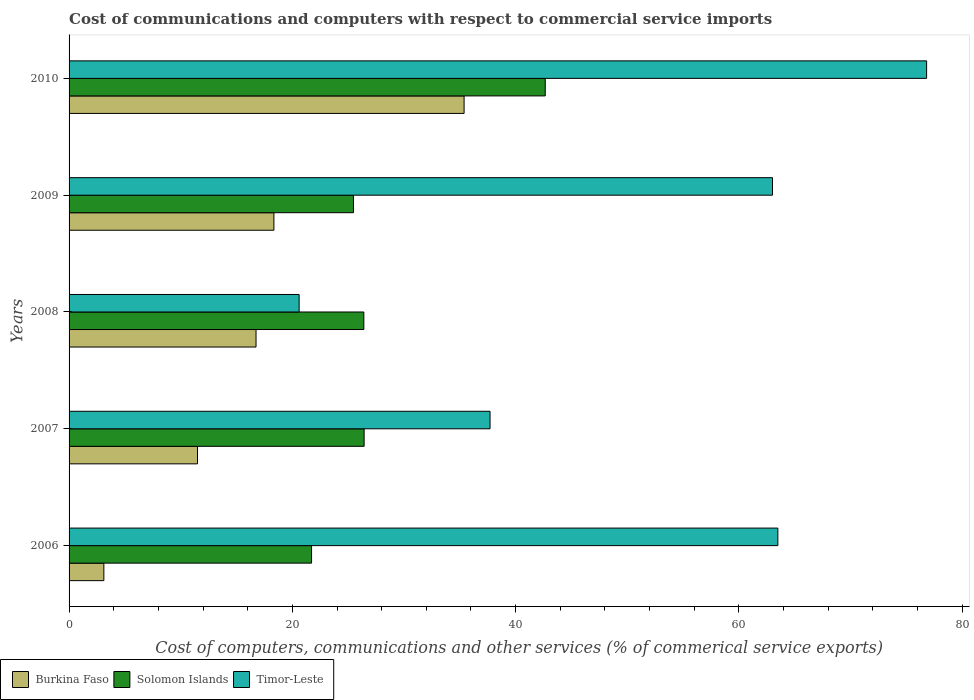How many groups of bars are there?
Your response must be concise. 5. Are the number of bars per tick equal to the number of legend labels?
Your answer should be very brief. Yes. Are the number of bars on each tick of the Y-axis equal?
Ensure brevity in your answer.  Yes. In how many cases, is the number of bars for a given year not equal to the number of legend labels?
Keep it short and to the point. 0. What is the cost of communications and computers in Burkina Faso in 2006?
Offer a very short reply. 3.12. Across all years, what is the maximum cost of communications and computers in Burkina Faso?
Offer a very short reply. 35.38. Across all years, what is the minimum cost of communications and computers in Solomon Islands?
Give a very brief answer. 21.72. In which year was the cost of communications and computers in Timor-Leste maximum?
Offer a very short reply. 2010. What is the total cost of communications and computers in Timor-Leste in the graph?
Keep it short and to the point. 261.62. What is the difference between the cost of communications and computers in Solomon Islands in 2006 and that in 2010?
Offer a terse response. -20.93. What is the difference between the cost of communications and computers in Timor-Leste in 2010 and the cost of communications and computers in Burkina Faso in 2009?
Make the answer very short. 58.46. What is the average cost of communications and computers in Burkina Faso per year?
Your answer should be very brief. 17.02. In the year 2006, what is the difference between the cost of communications and computers in Timor-Leste and cost of communications and computers in Burkina Faso?
Offer a terse response. 60.37. In how many years, is the cost of communications and computers in Timor-Leste greater than 56 %?
Make the answer very short. 3. What is the ratio of the cost of communications and computers in Burkina Faso in 2008 to that in 2010?
Ensure brevity in your answer.  0.47. Is the difference between the cost of communications and computers in Timor-Leste in 2007 and 2008 greater than the difference between the cost of communications and computers in Burkina Faso in 2007 and 2008?
Your response must be concise. Yes. What is the difference between the highest and the second highest cost of communications and computers in Solomon Islands?
Offer a very short reply. 16.22. What is the difference between the highest and the lowest cost of communications and computers in Burkina Faso?
Your response must be concise. 32.27. In how many years, is the cost of communications and computers in Solomon Islands greater than the average cost of communications and computers in Solomon Islands taken over all years?
Keep it short and to the point. 1. Is the sum of the cost of communications and computers in Timor-Leste in 2007 and 2008 greater than the maximum cost of communications and computers in Solomon Islands across all years?
Offer a terse response. Yes. What does the 1st bar from the top in 2006 represents?
Provide a succinct answer. Timor-Leste. What does the 2nd bar from the bottom in 2009 represents?
Your answer should be very brief. Solomon Islands. Is it the case that in every year, the sum of the cost of communications and computers in Burkina Faso and cost of communications and computers in Solomon Islands is greater than the cost of communications and computers in Timor-Leste?
Your response must be concise. No. Are all the bars in the graph horizontal?
Provide a succinct answer. Yes. How many years are there in the graph?
Provide a short and direct response. 5. What is the difference between two consecutive major ticks on the X-axis?
Make the answer very short. 20. Are the values on the major ticks of X-axis written in scientific E-notation?
Ensure brevity in your answer.  No. Does the graph contain grids?
Your answer should be very brief. No. How many legend labels are there?
Offer a very short reply. 3. What is the title of the graph?
Ensure brevity in your answer.  Cost of communications and computers with respect to commercial service imports. What is the label or title of the X-axis?
Provide a short and direct response. Cost of computers, communications and other services (% of commerical service exports). What is the label or title of the Y-axis?
Offer a terse response. Years. What is the Cost of computers, communications and other services (% of commerical service exports) of Burkina Faso in 2006?
Provide a succinct answer. 3.12. What is the Cost of computers, communications and other services (% of commerical service exports) of Solomon Islands in 2006?
Ensure brevity in your answer.  21.72. What is the Cost of computers, communications and other services (% of commerical service exports) in Timor-Leste in 2006?
Keep it short and to the point. 63.49. What is the Cost of computers, communications and other services (% of commerical service exports) in Burkina Faso in 2007?
Your response must be concise. 11.51. What is the Cost of computers, communications and other services (% of commerical service exports) in Solomon Islands in 2007?
Offer a terse response. 26.43. What is the Cost of computers, communications and other services (% of commerical service exports) in Timor-Leste in 2007?
Offer a terse response. 37.71. What is the Cost of computers, communications and other services (% of commerical service exports) of Burkina Faso in 2008?
Your answer should be very brief. 16.75. What is the Cost of computers, communications and other services (% of commerical service exports) of Solomon Islands in 2008?
Keep it short and to the point. 26.4. What is the Cost of computers, communications and other services (% of commerical service exports) of Timor-Leste in 2008?
Your answer should be very brief. 20.61. What is the Cost of computers, communications and other services (% of commerical service exports) in Burkina Faso in 2009?
Your answer should be compact. 18.35. What is the Cost of computers, communications and other services (% of commerical service exports) in Solomon Islands in 2009?
Your answer should be very brief. 25.47. What is the Cost of computers, communications and other services (% of commerical service exports) of Timor-Leste in 2009?
Ensure brevity in your answer.  63.01. What is the Cost of computers, communications and other services (% of commerical service exports) of Burkina Faso in 2010?
Provide a succinct answer. 35.38. What is the Cost of computers, communications and other services (% of commerical service exports) of Solomon Islands in 2010?
Ensure brevity in your answer.  42.65. What is the Cost of computers, communications and other services (% of commerical service exports) of Timor-Leste in 2010?
Ensure brevity in your answer.  76.81. Across all years, what is the maximum Cost of computers, communications and other services (% of commerical service exports) in Burkina Faso?
Make the answer very short. 35.38. Across all years, what is the maximum Cost of computers, communications and other services (% of commerical service exports) in Solomon Islands?
Make the answer very short. 42.65. Across all years, what is the maximum Cost of computers, communications and other services (% of commerical service exports) of Timor-Leste?
Make the answer very short. 76.81. Across all years, what is the minimum Cost of computers, communications and other services (% of commerical service exports) in Burkina Faso?
Offer a very short reply. 3.12. Across all years, what is the minimum Cost of computers, communications and other services (% of commerical service exports) of Solomon Islands?
Your response must be concise. 21.72. Across all years, what is the minimum Cost of computers, communications and other services (% of commerical service exports) of Timor-Leste?
Make the answer very short. 20.61. What is the total Cost of computers, communications and other services (% of commerical service exports) in Burkina Faso in the graph?
Offer a terse response. 85.1. What is the total Cost of computers, communications and other services (% of commerical service exports) of Solomon Islands in the graph?
Ensure brevity in your answer.  142.68. What is the total Cost of computers, communications and other services (% of commerical service exports) of Timor-Leste in the graph?
Your answer should be compact. 261.62. What is the difference between the Cost of computers, communications and other services (% of commerical service exports) in Burkina Faso in 2006 and that in 2007?
Make the answer very short. -8.39. What is the difference between the Cost of computers, communications and other services (% of commerical service exports) in Solomon Islands in 2006 and that in 2007?
Keep it short and to the point. -4.71. What is the difference between the Cost of computers, communications and other services (% of commerical service exports) of Timor-Leste in 2006 and that in 2007?
Give a very brief answer. 25.78. What is the difference between the Cost of computers, communications and other services (% of commerical service exports) in Burkina Faso in 2006 and that in 2008?
Keep it short and to the point. -13.63. What is the difference between the Cost of computers, communications and other services (% of commerical service exports) of Solomon Islands in 2006 and that in 2008?
Make the answer very short. -4.68. What is the difference between the Cost of computers, communications and other services (% of commerical service exports) in Timor-Leste in 2006 and that in 2008?
Provide a succinct answer. 42.88. What is the difference between the Cost of computers, communications and other services (% of commerical service exports) of Burkina Faso in 2006 and that in 2009?
Provide a short and direct response. -15.23. What is the difference between the Cost of computers, communications and other services (% of commerical service exports) in Solomon Islands in 2006 and that in 2009?
Ensure brevity in your answer.  -3.75. What is the difference between the Cost of computers, communications and other services (% of commerical service exports) in Timor-Leste in 2006 and that in 2009?
Your response must be concise. 0.48. What is the difference between the Cost of computers, communications and other services (% of commerical service exports) of Burkina Faso in 2006 and that in 2010?
Provide a short and direct response. -32.27. What is the difference between the Cost of computers, communications and other services (% of commerical service exports) of Solomon Islands in 2006 and that in 2010?
Offer a very short reply. -20.93. What is the difference between the Cost of computers, communications and other services (% of commerical service exports) of Timor-Leste in 2006 and that in 2010?
Provide a short and direct response. -13.32. What is the difference between the Cost of computers, communications and other services (% of commerical service exports) of Burkina Faso in 2007 and that in 2008?
Give a very brief answer. -5.24. What is the difference between the Cost of computers, communications and other services (% of commerical service exports) in Solomon Islands in 2007 and that in 2008?
Your response must be concise. 0.03. What is the difference between the Cost of computers, communications and other services (% of commerical service exports) in Timor-Leste in 2007 and that in 2008?
Provide a succinct answer. 17.1. What is the difference between the Cost of computers, communications and other services (% of commerical service exports) in Burkina Faso in 2007 and that in 2009?
Offer a very short reply. -6.84. What is the difference between the Cost of computers, communications and other services (% of commerical service exports) in Solomon Islands in 2007 and that in 2009?
Keep it short and to the point. 0.95. What is the difference between the Cost of computers, communications and other services (% of commerical service exports) in Timor-Leste in 2007 and that in 2009?
Your answer should be compact. -25.3. What is the difference between the Cost of computers, communications and other services (% of commerical service exports) in Burkina Faso in 2007 and that in 2010?
Your answer should be very brief. -23.88. What is the difference between the Cost of computers, communications and other services (% of commerical service exports) of Solomon Islands in 2007 and that in 2010?
Your answer should be very brief. -16.22. What is the difference between the Cost of computers, communications and other services (% of commerical service exports) in Timor-Leste in 2007 and that in 2010?
Keep it short and to the point. -39.1. What is the difference between the Cost of computers, communications and other services (% of commerical service exports) in Burkina Faso in 2008 and that in 2009?
Ensure brevity in your answer.  -1.6. What is the difference between the Cost of computers, communications and other services (% of commerical service exports) in Solomon Islands in 2008 and that in 2009?
Offer a very short reply. 0.93. What is the difference between the Cost of computers, communications and other services (% of commerical service exports) in Timor-Leste in 2008 and that in 2009?
Your answer should be very brief. -42.4. What is the difference between the Cost of computers, communications and other services (% of commerical service exports) in Burkina Faso in 2008 and that in 2010?
Offer a very short reply. -18.64. What is the difference between the Cost of computers, communications and other services (% of commerical service exports) of Solomon Islands in 2008 and that in 2010?
Your answer should be very brief. -16.25. What is the difference between the Cost of computers, communications and other services (% of commerical service exports) of Timor-Leste in 2008 and that in 2010?
Ensure brevity in your answer.  -56.21. What is the difference between the Cost of computers, communications and other services (% of commerical service exports) in Burkina Faso in 2009 and that in 2010?
Provide a succinct answer. -17.04. What is the difference between the Cost of computers, communications and other services (% of commerical service exports) in Solomon Islands in 2009 and that in 2010?
Keep it short and to the point. -17.18. What is the difference between the Cost of computers, communications and other services (% of commerical service exports) of Timor-Leste in 2009 and that in 2010?
Provide a short and direct response. -13.8. What is the difference between the Cost of computers, communications and other services (% of commerical service exports) in Burkina Faso in 2006 and the Cost of computers, communications and other services (% of commerical service exports) in Solomon Islands in 2007?
Provide a succinct answer. -23.31. What is the difference between the Cost of computers, communications and other services (% of commerical service exports) in Burkina Faso in 2006 and the Cost of computers, communications and other services (% of commerical service exports) in Timor-Leste in 2007?
Ensure brevity in your answer.  -34.59. What is the difference between the Cost of computers, communications and other services (% of commerical service exports) of Solomon Islands in 2006 and the Cost of computers, communications and other services (% of commerical service exports) of Timor-Leste in 2007?
Offer a very short reply. -15.99. What is the difference between the Cost of computers, communications and other services (% of commerical service exports) of Burkina Faso in 2006 and the Cost of computers, communications and other services (% of commerical service exports) of Solomon Islands in 2008?
Provide a short and direct response. -23.29. What is the difference between the Cost of computers, communications and other services (% of commerical service exports) in Burkina Faso in 2006 and the Cost of computers, communications and other services (% of commerical service exports) in Timor-Leste in 2008?
Give a very brief answer. -17.49. What is the difference between the Cost of computers, communications and other services (% of commerical service exports) in Solomon Islands in 2006 and the Cost of computers, communications and other services (% of commerical service exports) in Timor-Leste in 2008?
Give a very brief answer. 1.12. What is the difference between the Cost of computers, communications and other services (% of commerical service exports) in Burkina Faso in 2006 and the Cost of computers, communications and other services (% of commerical service exports) in Solomon Islands in 2009?
Ensure brevity in your answer.  -22.36. What is the difference between the Cost of computers, communications and other services (% of commerical service exports) in Burkina Faso in 2006 and the Cost of computers, communications and other services (% of commerical service exports) in Timor-Leste in 2009?
Your answer should be very brief. -59.89. What is the difference between the Cost of computers, communications and other services (% of commerical service exports) of Solomon Islands in 2006 and the Cost of computers, communications and other services (% of commerical service exports) of Timor-Leste in 2009?
Your answer should be very brief. -41.29. What is the difference between the Cost of computers, communications and other services (% of commerical service exports) of Burkina Faso in 2006 and the Cost of computers, communications and other services (% of commerical service exports) of Solomon Islands in 2010?
Your response must be concise. -39.54. What is the difference between the Cost of computers, communications and other services (% of commerical service exports) in Burkina Faso in 2006 and the Cost of computers, communications and other services (% of commerical service exports) in Timor-Leste in 2010?
Ensure brevity in your answer.  -73.7. What is the difference between the Cost of computers, communications and other services (% of commerical service exports) of Solomon Islands in 2006 and the Cost of computers, communications and other services (% of commerical service exports) of Timor-Leste in 2010?
Your response must be concise. -55.09. What is the difference between the Cost of computers, communications and other services (% of commerical service exports) in Burkina Faso in 2007 and the Cost of computers, communications and other services (% of commerical service exports) in Solomon Islands in 2008?
Provide a succinct answer. -14.9. What is the difference between the Cost of computers, communications and other services (% of commerical service exports) of Burkina Faso in 2007 and the Cost of computers, communications and other services (% of commerical service exports) of Timor-Leste in 2008?
Provide a short and direct response. -9.1. What is the difference between the Cost of computers, communications and other services (% of commerical service exports) in Solomon Islands in 2007 and the Cost of computers, communications and other services (% of commerical service exports) in Timor-Leste in 2008?
Your answer should be compact. 5.82. What is the difference between the Cost of computers, communications and other services (% of commerical service exports) in Burkina Faso in 2007 and the Cost of computers, communications and other services (% of commerical service exports) in Solomon Islands in 2009?
Offer a terse response. -13.97. What is the difference between the Cost of computers, communications and other services (% of commerical service exports) in Burkina Faso in 2007 and the Cost of computers, communications and other services (% of commerical service exports) in Timor-Leste in 2009?
Provide a short and direct response. -51.5. What is the difference between the Cost of computers, communications and other services (% of commerical service exports) of Solomon Islands in 2007 and the Cost of computers, communications and other services (% of commerical service exports) of Timor-Leste in 2009?
Offer a very short reply. -36.58. What is the difference between the Cost of computers, communications and other services (% of commerical service exports) in Burkina Faso in 2007 and the Cost of computers, communications and other services (% of commerical service exports) in Solomon Islands in 2010?
Offer a terse response. -31.15. What is the difference between the Cost of computers, communications and other services (% of commerical service exports) of Burkina Faso in 2007 and the Cost of computers, communications and other services (% of commerical service exports) of Timor-Leste in 2010?
Your answer should be very brief. -65.31. What is the difference between the Cost of computers, communications and other services (% of commerical service exports) of Solomon Islands in 2007 and the Cost of computers, communications and other services (% of commerical service exports) of Timor-Leste in 2010?
Make the answer very short. -50.38. What is the difference between the Cost of computers, communications and other services (% of commerical service exports) of Burkina Faso in 2008 and the Cost of computers, communications and other services (% of commerical service exports) of Solomon Islands in 2009?
Provide a succinct answer. -8.73. What is the difference between the Cost of computers, communications and other services (% of commerical service exports) of Burkina Faso in 2008 and the Cost of computers, communications and other services (% of commerical service exports) of Timor-Leste in 2009?
Provide a short and direct response. -46.26. What is the difference between the Cost of computers, communications and other services (% of commerical service exports) in Solomon Islands in 2008 and the Cost of computers, communications and other services (% of commerical service exports) in Timor-Leste in 2009?
Keep it short and to the point. -36.61. What is the difference between the Cost of computers, communications and other services (% of commerical service exports) in Burkina Faso in 2008 and the Cost of computers, communications and other services (% of commerical service exports) in Solomon Islands in 2010?
Keep it short and to the point. -25.9. What is the difference between the Cost of computers, communications and other services (% of commerical service exports) of Burkina Faso in 2008 and the Cost of computers, communications and other services (% of commerical service exports) of Timor-Leste in 2010?
Ensure brevity in your answer.  -60.06. What is the difference between the Cost of computers, communications and other services (% of commerical service exports) of Solomon Islands in 2008 and the Cost of computers, communications and other services (% of commerical service exports) of Timor-Leste in 2010?
Your answer should be very brief. -50.41. What is the difference between the Cost of computers, communications and other services (% of commerical service exports) in Burkina Faso in 2009 and the Cost of computers, communications and other services (% of commerical service exports) in Solomon Islands in 2010?
Provide a succinct answer. -24.3. What is the difference between the Cost of computers, communications and other services (% of commerical service exports) of Burkina Faso in 2009 and the Cost of computers, communications and other services (% of commerical service exports) of Timor-Leste in 2010?
Your answer should be compact. -58.46. What is the difference between the Cost of computers, communications and other services (% of commerical service exports) in Solomon Islands in 2009 and the Cost of computers, communications and other services (% of commerical service exports) in Timor-Leste in 2010?
Provide a short and direct response. -51.34. What is the average Cost of computers, communications and other services (% of commerical service exports) of Burkina Faso per year?
Keep it short and to the point. 17.02. What is the average Cost of computers, communications and other services (% of commerical service exports) of Solomon Islands per year?
Ensure brevity in your answer.  28.54. What is the average Cost of computers, communications and other services (% of commerical service exports) in Timor-Leste per year?
Your response must be concise. 52.32. In the year 2006, what is the difference between the Cost of computers, communications and other services (% of commerical service exports) of Burkina Faso and Cost of computers, communications and other services (% of commerical service exports) of Solomon Islands?
Make the answer very short. -18.61. In the year 2006, what is the difference between the Cost of computers, communications and other services (% of commerical service exports) of Burkina Faso and Cost of computers, communications and other services (% of commerical service exports) of Timor-Leste?
Your answer should be compact. -60.37. In the year 2006, what is the difference between the Cost of computers, communications and other services (% of commerical service exports) of Solomon Islands and Cost of computers, communications and other services (% of commerical service exports) of Timor-Leste?
Give a very brief answer. -41.77. In the year 2007, what is the difference between the Cost of computers, communications and other services (% of commerical service exports) in Burkina Faso and Cost of computers, communications and other services (% of commerical service exports) in Solomon Islands?
Your answer should be compact. -14.92. In the year 2007, what is the difference between the Cost of computers, communications and other services (% of commerical service exports) of Burkina Faso and Cost of computers, communications and other services (% of commerical service exports) of Timor-Leste?
Ensure brevity in your answer.  -26.2. In the year 2007, what is the difference between the Cost of computers, communications and other services (% of commerical service exports) of Solomon Islands and Cost of computers, communications and other services (% of commerical service exports) of Timor-Leste?
Give a very brief answer. -11.28. In the year 2008, what is the difference between the Cost of computers, communications and other services (% of commerical service exports) of Burkina Faso and Cost of computers, communications and other services (% of commerical service exports) of Solomon Islands?
Keep it short and to the point. -9.65. In the year 2008, what is the difference between the Cost of computers, communications and other services (% of commerical service exports) in Burkina Faso and Cost of computers, communications and other services (% of commerical service exports) in Timor-Leste?
Offer a very short reply. -3.86. In the year 2008, what is the difference between the Cost of computers, communications and other services (% of commerical service exports) of Solomon Islands and Cost of computers, communications and other services (% of commerical service exports) of Timor-Leste?
Provide a short and direct response. 5.8. In the year 2009, what is the difference between the Cost of computers, communications and other services (% of commerical service exports) of Burkina Faso and Cost of computers, communications and other services (% of commerical service exports) of Solomon Islands?
Provide a short and direct response. -7.13. In the year 2009, what is the difference between the Cost of computers, communications and other services (% of commerical service exports) of Burkina Faso and Cost of computers, communications and other services (% of commerical service exports) of Timor-Leste?
Offer a terse response. -44.66. In the year 2009, what is the difference between the Cost of computers, communications and other services (% of commerical service exports) of Solomon Islands and Cost of computers, communications and other services (% of commerical service exports) of Timor-Leste?
Offer a very short reply. -37.53. In the year 2010, what is the difference between the Cost of computers, communications and other services (% of commerical service exports) in Burkina Faso and Cost of computers, communications and other services (% of commerical service exports) in Solomon Islands?
Offer a very short reply. -7.27. In the year 2010, what is the difference between the Cost of computers, communications and other services (% of commerical service exports) of Burkina Faso and Cost of computers, communications and other services (% of commerical service exports) of Timor-Leste?
Ensure brevity in your answer.  -41.43. In the year 2010, what is the difference between the Cost of computers, communications and other services (% of commerical service exports) in Solomon Islands and Cost of computers, communications and other services (% of commerical service exports) in Timor-Leste?
Offer a terse response. -34.16. What is the ratio of the Cost of computers, communications and other services (% of commerical service exports) in Burkina Faso in 2006 to that in 2007?
Keep it short and to the point. 0.27. What is the ratio of the Cost of computers, communications and other services (% of commerical service exports) of Solomon Islands in 2006 to that in 2007?
Offer a very short reply. 0.82. What is the ratio of the Cost of computers, communications and other services (% of commerical service exports) in Timor-Leste in 2006 to that in 2007?
Your answer should be very brief. 1.68. What is the ratio of the Cost of computers, communications and other services (% of commerical service exports) of Burkina Faso in 2006 to that in 2008?
Provide a succinct answer. 0.19. What is the ratio of the Cost of computers, communications and other services (% of commerical service exports) in Solomon Islands in 2006 to that in 2008?
Offer a very short reply. 0.82. What is the ratio of the Cost of computers, communications and other services (% of commerical service exports) in Timor-Leste in 2006 to that in 2008?
Make the answer very short. 3.08. What is the ratio of the Cost of computers, communications and other services (% of commerical service exports) in Burkina Faso in 2006 to that in 2009?
Offer a very short reply. 0.17. What is the ratio of the Cost of computers, communications and other services (% of commerical service exports) in Solomon Islands in 2006 to that in 2009?
Provide a succinct answer. 0.85. What is the ratio of the Cost of computers, communications and other services (% of commerical service exports) of Timor-Leste in 2006 to that in 2009?
Provide a succinct answer. 1.01. What is the ratio of the Cost of computers, communications and other services (% of commerical service exports) in Burkina Faso in 2006 to that in 2010?
Provide a short and direct response. 0.09. What is the ratio of the Cost of computers, communications and other services (% of commerical service exports) in Solomon Islands in 2006 to that in 2010?
Provide a short and direct response. 0.51. What is the ratio of the Cost of computers, communications and other services (% of commerical service exports) of Timor-Leste in 2006 to that in 2010?
Keep it short and to the point. 0.83. What is the ratio of the Cost of computers, communications and other services (% of commerical service exports) in Burkina Faso in 2007 to that in 2008?
Keep it short and to the point. 0.69. What is the ratio of the Cost of computers, communications and other services (% of commerical service exports) of Solomon Islands in 2007 to that in 2008?
Give a very brief answer. 1. What is the ratio of the Cost of computers, communications and other services (% of commerical service exports) in Timor-Leste in 2007 to that in 2008?
Give a very brief answer. 1.83. What is the ratio of the Cost of computers, communications and other services (% of commerical service exports) in Burkina Faso in 2007 to that in 2009?
Offer a terse response. 0.63. What is the ratio of the Cost of computers, communications and other services (% of commerical service exports) in Solomon Islands in 2007 to that in 2009?
Make the answer very short. 1.04. What is the ratio of the Cost of computers, communications and other services (% of commerical service exports) in Timor-Leste in 2007 to that in 2009?
Provide a succinct answer. 0.6. What is the ratio of the Cost of computers, communications and other services (% of commerical service exports) in Burkina Faso in 2007 to that in 2010?
Provide a succinct answer. 0.33. What is the ratio of the Cost of computers, communications and other services (% of commerical service exports) of Solomon Islands in 2007 to that in 2010?
Your answer should be compact. 0.62. What is the ratio of the Cost of computers, communications and other services (% of commerical service exports) of Timor-Leste in 2007 to that in 2010?
Your response must be concise. 0.49. What is the ratio of the Cost of computers, communications and other services (% of commerical service exports) of Burkina Faso in 2008 to that in 2009?
Your response must be concise. 0.91. What is the ratio of the Cost of computers, communications and other services (% of commerical service exports) in Solomon Islands in 2008 to that in 2009?
Offer a terse response. 1.04. What is the ratio of the Cost of computers, communications and other services (% of commerical service exports) in Timor-Leste in 2008 to that in 2009?
Offer a very short reply. 0.33. What is the ratio of the Cost of computers, communications and other services (% of commerical service exports) in Burkina Faso in 2008 to that in 2010?
Provide a succinct answer. 0.47. What is the ratio of the Cost of computers, communications and other services (% of commerical service exports) in Solomon Islands in 2008 to that in 2010?
Offer a terse response. 0.62. What is the ratio of the Cost of computers, communications and other services (% of commerical service exports) of Timor-Leste in 2008 to that in 2010?
Provide a succinct answer. 0.27. What is the ratio of the Cost of computers, communications and other services (% of commerical service exports) in Burkina Faso in 2009 to that in 2010?
Provide a succinct answer. 0.52. What is the ratio of the Cost of computers, communications and other services (% of commerical service exports) of Solomon Islands in 2009 to that in 2010?
Ensure brevity in your answer.  0.6. What is the ratio of the Cost of computers, communications and other services (% of commerical service exports) in Timor-Leste in 2009 to that in 2010?
Make the answer very short. 0.82. What is the difference between the highest and the second highest Cost of computers, communications and other services (% of commerical service exports) in Burkina Faso?
Your response must be concise. 17.04. What is the difference between the highest and the second highest Cost of computers, communications and other services (% of commerical service exports) in Solomon Islands?
Your answer should be compact. 16.22. What is the difference between the highest and the second highest Cost of computers, communications and other services (% of commerical service exports) in Timor-Leste?
Provide a succinct answer. 13.32. What is the difference between the highest and the lowest Cost of computers, communications and other services (% of commerical service exports) of Burkina Faso?
Ensure brevity in your answer.  32.27. What is the difference between the highest and the lowest Cost of computers, communications and other services (% of commerical service exports) of Solomon Islands?
Offer a very short reply. 20.93. What is the difference between the highest and the lowest Cost of computers, communications and other services (% of commerical service exports) of Timor-Leste?
Keep it short and to the point. 56.21. 